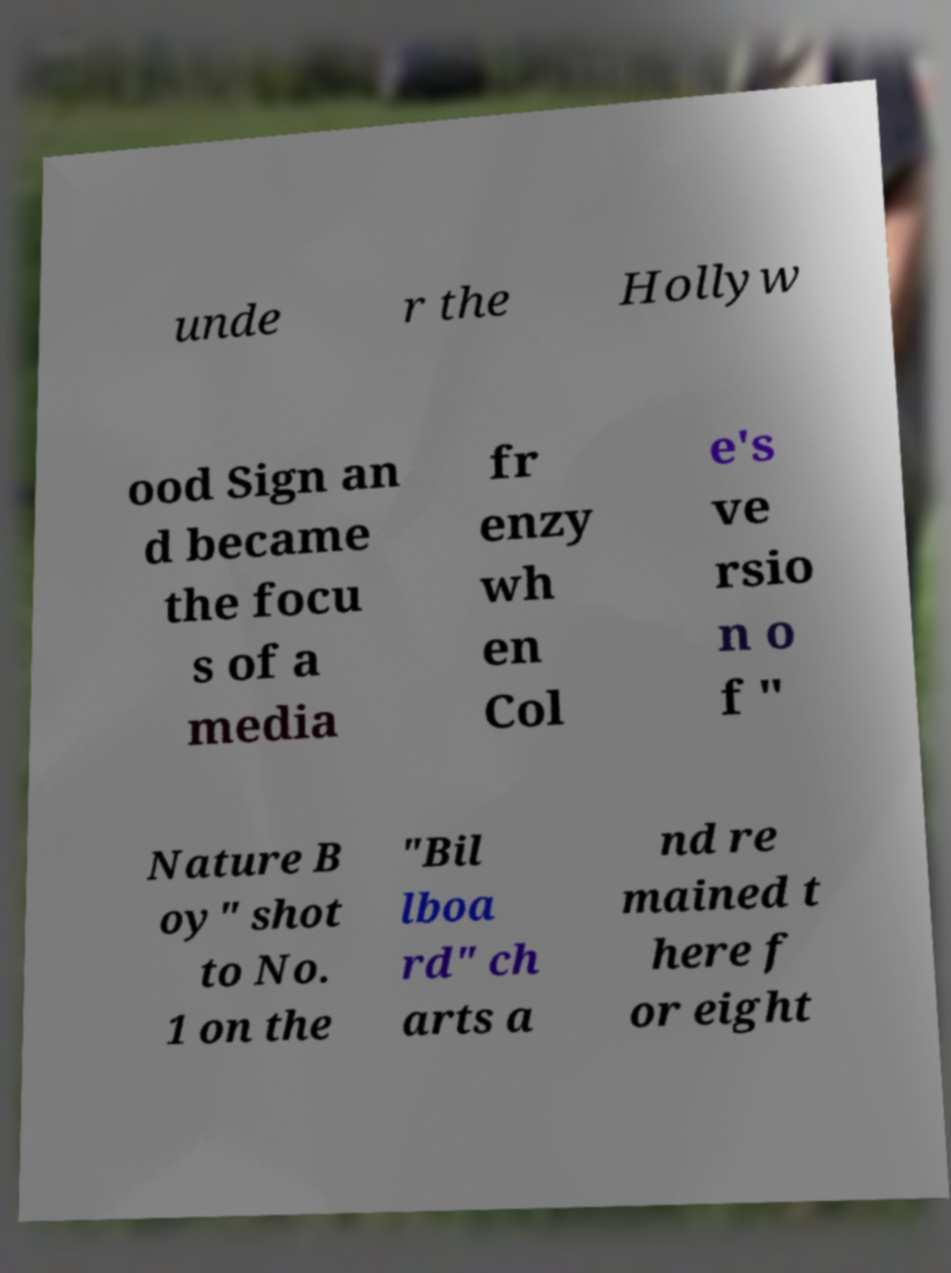For documentation purposes, I need the text within this image transcribed. Could you provide that? unde r the Hollyw ood Sign an d became the focu s of a media fr enzy wh en Col e's ve rsio n o f " Nature B oy" shot to No. 1 on the "Bil lboa rd" ch arts a nd re mained t here f or eight 